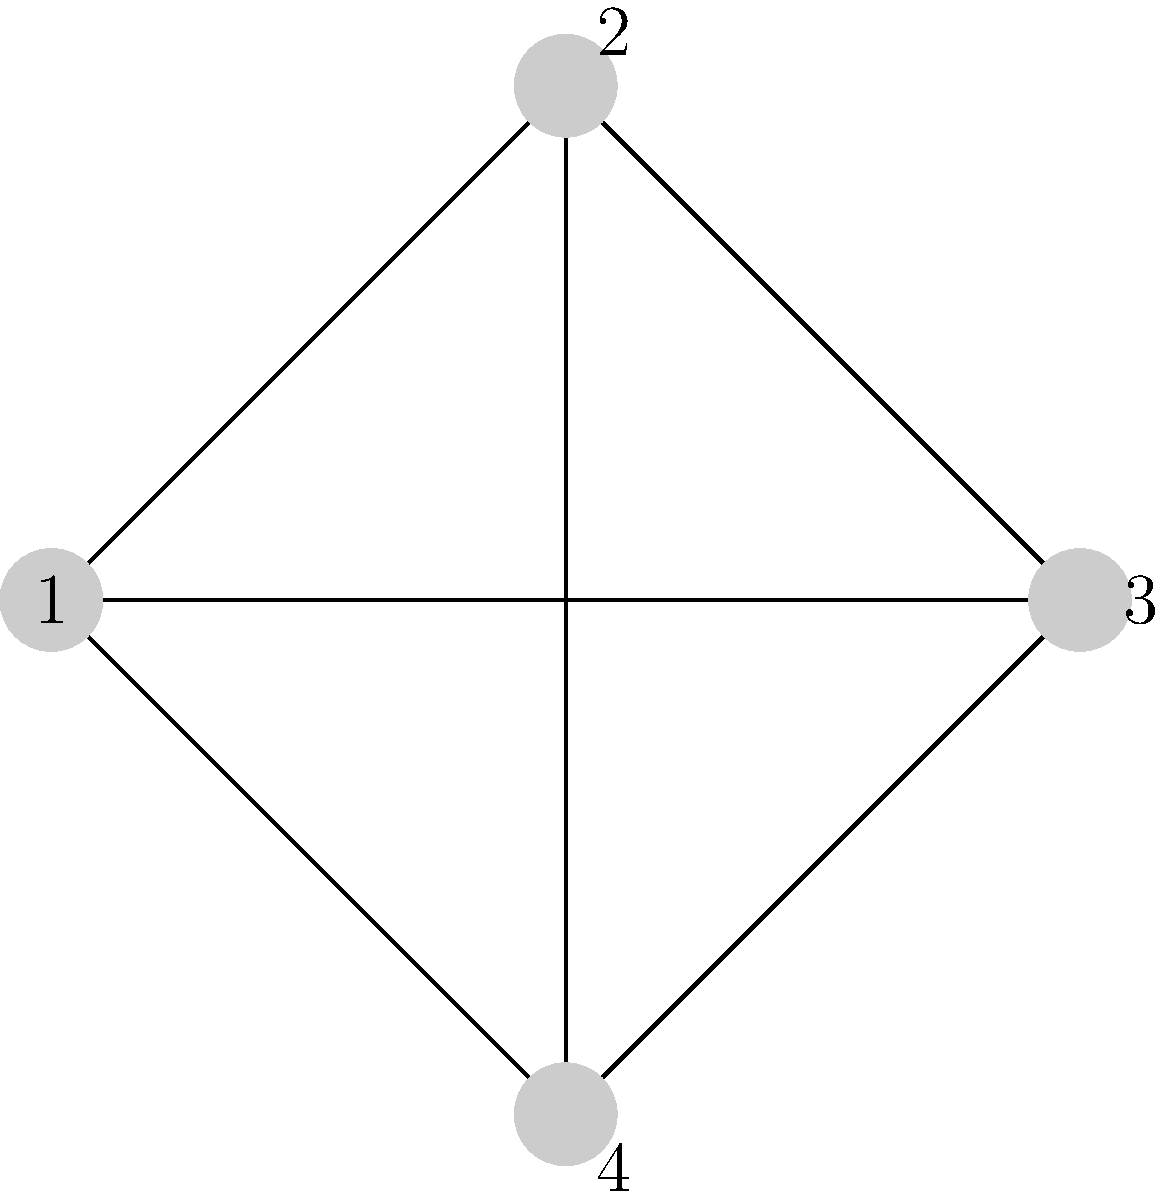Consider the graph shown above, which represents a scheduling problem where vertices are tasks and edges indicate conflicts between tasks. What is the minimum number of time slots (colors) needed to schedule all tasks without conflicts, and how does this relate to the graph's chromatic number? To determine the minimum number of time slots needed, we need to find the chromatic number of the graph. Let's approach this step-by-step:

1. Observe that the graph is a complete graph with 4 vertices (K4), meaning every vertex is connected to every other vertex.

2. In a complete graph, each vertex must have a different color (or time slot) because it's connected to all other vertices.

3. The chromatic number of a complete graph with n vertices is always n.

4. In this case, we have 4 vertices, so the chromatic number is 4.

5. This means we need at least 4 different colors (time slots) to color the graph properly (schedule all tasks without conflicts).

6. The chromatic number directly corresponds to the minimum number of time slots needed in the scheduling problem.

This example illustrates how graph coloring can be applied to scheduling problems. Each color represents a time slot, and the chromatic number gives us the minimum number of time slots required to schedule all tasks without conflicts.
Answer: 4 time slots; equal to the graph's chromatic number. 